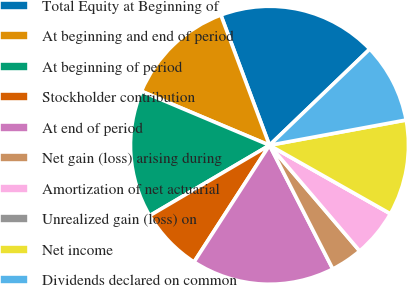Convert chart to OTSL. <chart><loc_0><loc_0><loc_500><loc_500><pie_chart><fcel>Total Equity at Beginning of<fcel>At beginning and end of period<fcel>At beginning of period<fcel>Stockholder contribution<fcel>At end of period<fcel>Net gain (loss) arising during<fcel>Amortization of net actuarial<fcel>Unrealized gain (loss) on<fcel>Net income<fcel>Dividends declared on common<nl><fcel>18.52%<fcel>12.96%<fcel>14.81%<fcel>7.41%<fcel>16.66%<fcel>3.71%<fcel>5.56%<fcel>0.0%<fcel>11.11%<fcel>9.26%<nl></chart> 